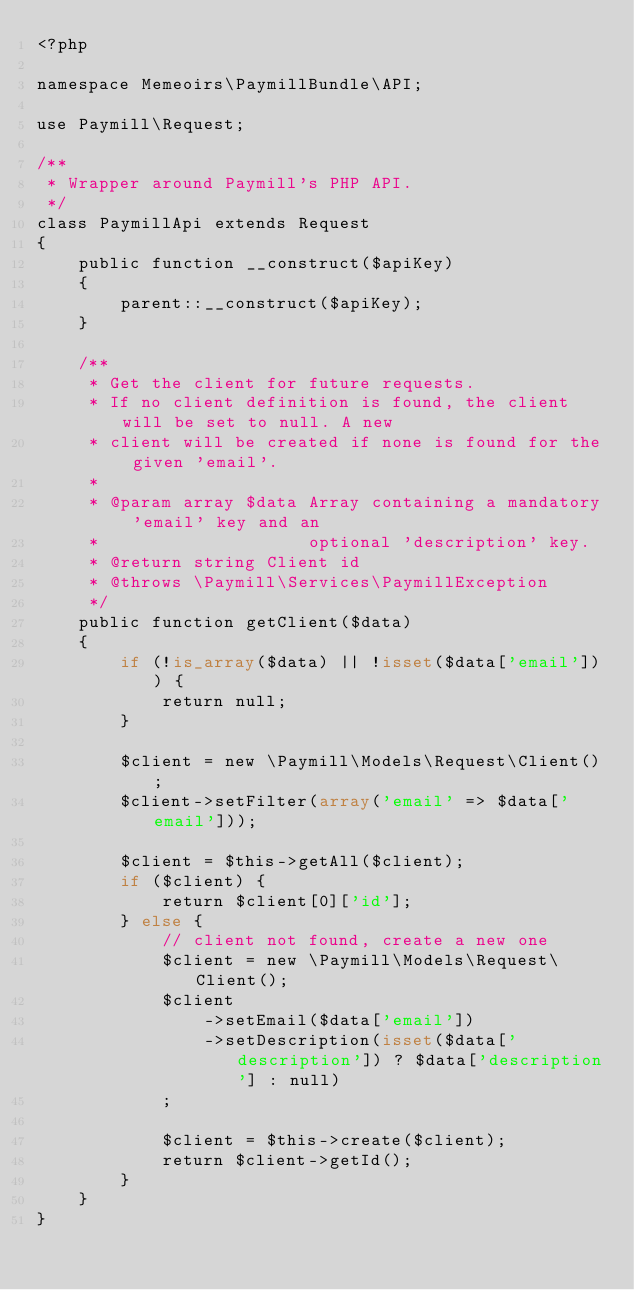Convert code to text. <code><loc_0><loc_0><loc_500><loc_500><_PHP_><?php

namespace Memeoirs\PaymillBundle\API;

use Paymill\Request;

/**
 * Wrapper around Paymill's PHP API.
 */
class PaymillApi extends Request
{
    public function __construct($apiKey)
    {
        parent::__construct($apiKey);
    }

    /**
     * Get the client for future requests.
     * If no client definition is found, the client will be set to null. A new
     * client will be created if none is found for the given 'email'.
     *
     * @param array $data Array containing a mandatory 'email' key and an
     *                    optional 'description' key.
     * @return string Client id
     * @throws \Paymill\Services\PaymillException
     */
    public function getClient($data)
    {
        if (!is_array($data) || !isset($data['email'])) {
            return null;
        }

        $client = new \Paymill\Models\Request\Client();
        $client->setFilter(array('email' => $data['email']));

        $client = $this->getAll($client);
        if ($client) {
            return $client[0]['id'];
        } else {
            // client not found, create a new one
            $client = new \Paymill\Models\Request\Client();
            $client
                ->setEmail($data['email'])
                ->setDescription(isset($data['description']) ? $data['description'] : null)
            ;

            $client = $this->create($client);
            return $client->getId();
        }
    }
}</code> 